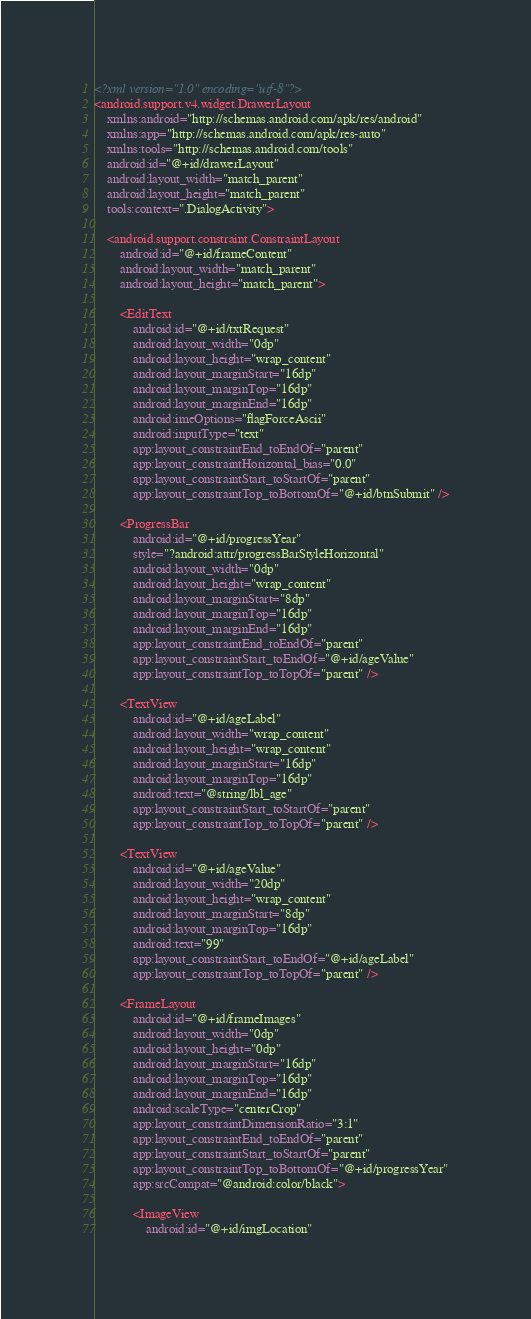Convert code to text. <code><loc_0><loc_0><loc_500><loc_500><_XML_><?xml version="1.0" encoding="utf-8"?>
<android.support.v4.widget.DrawerLayout
    xmlns:android="http://schemas.android.com/apk/res/android"
    xmlns:app="http://schemas.android.com/apk/res-auto"
    xmlns:tools="http://schemas.android.com/tools"
    android:id="@+id/drawerLayout"
    android:layout_width="match_parent"
    android:layout_height="match_parent"
    tools:context=".DialogActivity">

    <android.support.constraint.ConstraintLayout
        android:id="@+id/frameContent"
        android:layout_width="match_parent"
        android:layout_height="match_parent">

        <EditText
            android:id="@+id/txtRequest"
            android:layout_width="0dp"
            android:layout_height="wrap_content"
            android:layout_marginStart="16dp"
            android:layout_marginTop="16dp"
            android:layout_marginEnd="16dp"
            android:imeOptions="flagForceAscii"
            android:inputType="text"
            app:layout_constraintEnd_toEndOf="parent"
            app:layout_constraintHorizontal_bias="0.0"
            app:layout_constraintStart_toStartOf="parent"
            app:layout_constraintTop_toBottomOf="@+id/btnSubmit" />

        <ProgressBar
            android:id="@+id/progressYear"
            style="?android:attr/progressBarStyleHorizontal"
            android:layout_width="0dp"
            android:layout_height="wrap_content"
            android:layout_marginStart="8dp"
            android:layout_marginTop="16dp"
            android:layout_marginEnd="16dp"
            app:layout_constraintEnd_toEndOf="parent"
            app:layout_constraintStart_toEndOf="@+id/ageValue"
            app:layout_constraintTop_toTopOf="parent" />

        <TextView
            android:id="@+id/ageLabel"
            android:layout_width="wrap_content"
            android:layout_height="wrap_content"
            android:layout_marginStart="16dp"
            android:layout_marginTop="16dp"
            android:text="@string/lbl_age"
            app:layout_constraintStart_toStartOf="parent"
            app:layout_constraintTop_toTopOf="parent" />

        <TextView
            android:id="@+id/ageValue"
            android:layout_width="20dp"
            android:layout_height="wrap_content"
            android:layout_marginStart="8dp"
            android:layout_marginTop="16dp"
            android:text="99"
            app:layout_constraintStart_toEndOf="@+id/ageLabel"
            app:layout_constraintTop_toTopOf="parent" />

        <FrameLayout
            android:id="@+id/frameImages"
            android:layout_width="0dp"
            android:layout_height="0dp"
            android:layout_marginStart="16dp"
            android:layout_marginTop="16dp"
            android:layout_marginEnd="16dp"
            android:scaleType="centerCrop"
            app:layout_constraintDimensionRatio="3:1"
            app:layout_constraintEnd_toEndOf="parent"
            app:layout_constraintStart_toStartOf="parent"
            app:layout_constraintTop_toBottomOf="@+id/progressYear"
            app:srcCompat="@android:color/black">

            <ImageView
                android:id="@+id/imgLocation"</code> 